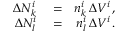<formula> <loc_0><loc_0><loc_500><loc_500>\begin{array} { r l r } { \Delta N _ { k } ^ { i } } & = } & { n _ { k } ^ { i } \, \Delta V ^ { i } \, , } \\ { \Delta N _ { l } ^ { i } } & = } & { n _ { l } ^ { i } \, \Delta V ^ { i } \, . } \end{array}</formula> 